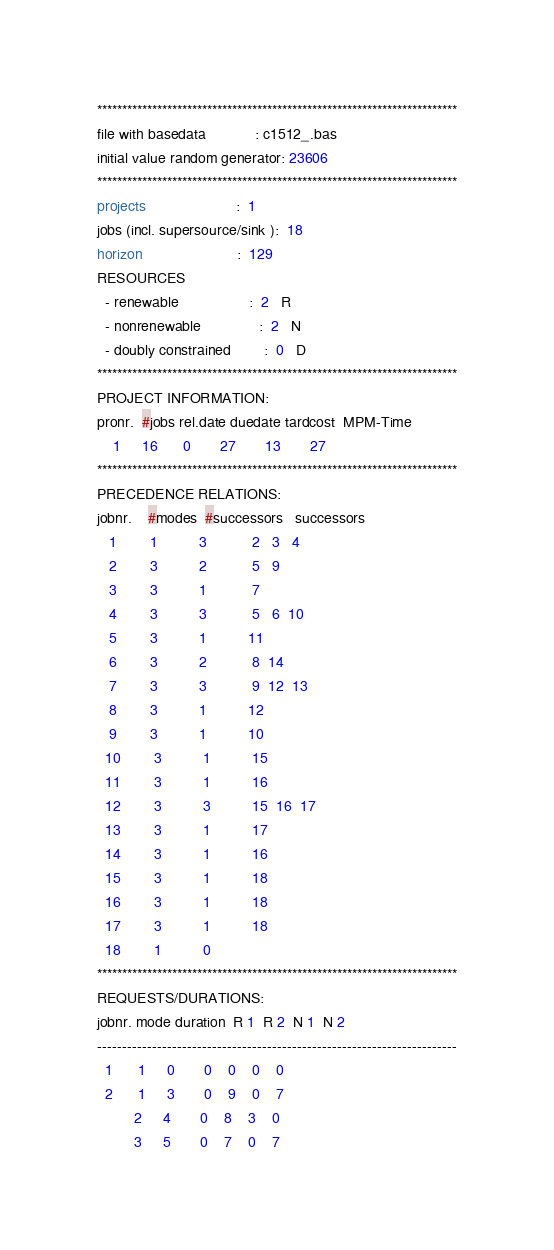Convert code to text. <code><loc_0><loc_0><loc_500><loc_500><_ObjectiveC_>************************************************************************
file with basedata            : c1512_.bas
initial value random generator: 23606
************************************************************************
projects                      :  1
jobs (incl. supersource/sink ):  18
horizon                       :  129
RESOURCES
  - renewable                 :  2   R
  - nonrenewable              :  2   N
  - doubly constrained        :  0   D
************************************************************************
PROJECT INFORMATION:
pronr.  #jobs rel.date duedate tardcost  MPM-Time
    1     16      0       27       13       27
************************************************************************
PRECEDENCE RELATIONS:
jobnr.    #modes  #successors   successors
   1        1          3           2   3   4
   2        3          2           5   9
   3        3          1           7
   4        3          3           5   6  10
   5        3          1          11
   6        3          2           8  14
   7        3          3           9  12  13
   8        3          1          12
   9        3          1          10
  10        3          1          15
  11        3          1          16
  12        3          3          15  16  17
  13        3          1          17
  14        3          1          16
  15        3          1          18
  16        3          1          18
  17        3          1          18
  18        1          0        
************************************************************************
REQUESTS/DURATIONS:
jobnr. mode duration  R 1  R 2  N 1  N 2
------------------------------------------------------------------------
  1      1     0       0    0    0    0
  2      1     3       0    9    0    7
         2     4       0    8    3    0
         3     5       0    7    0    7</code> 